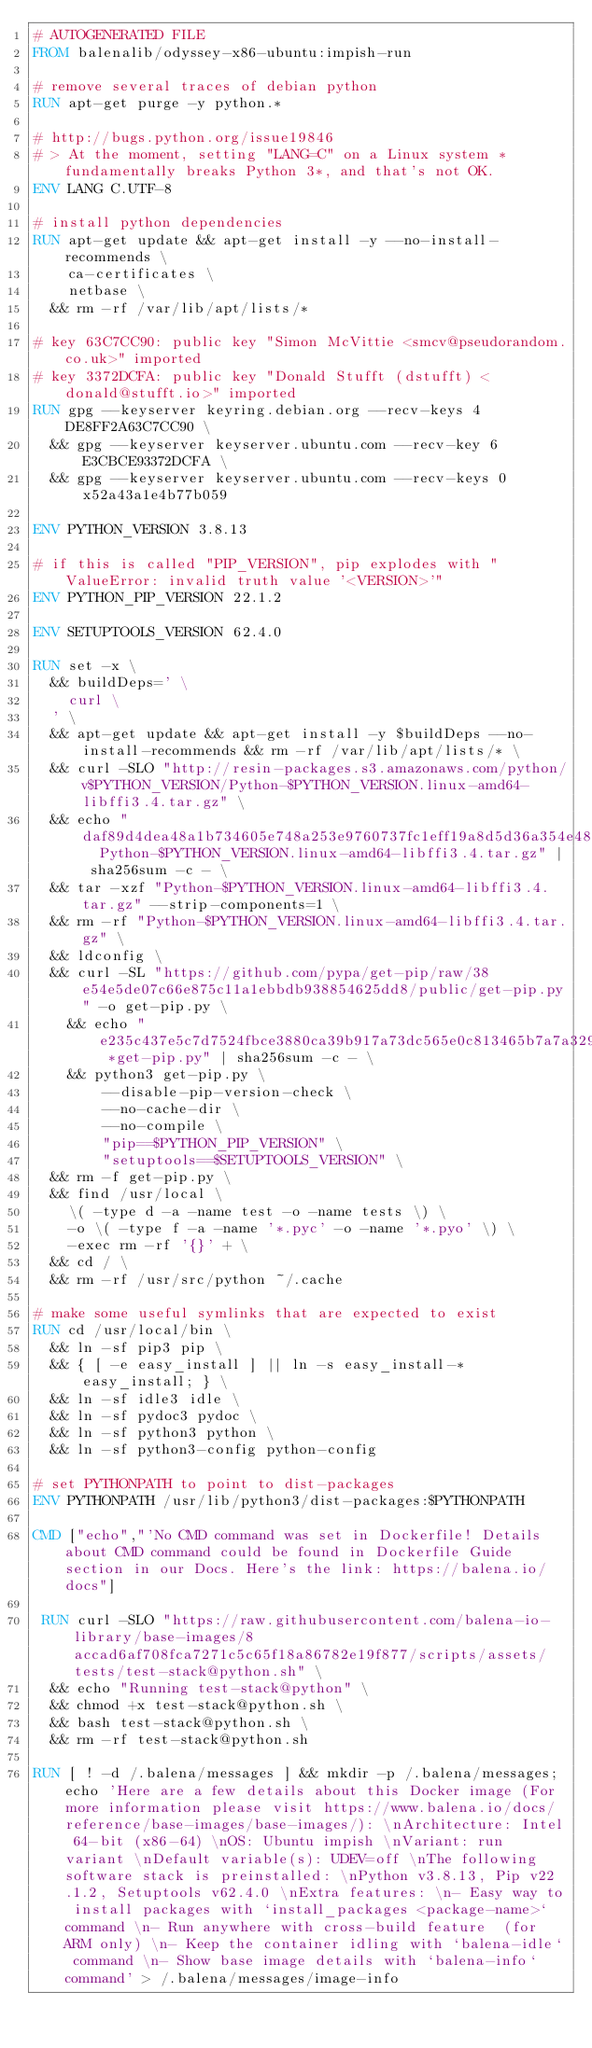<code> <loc_0><loc_0><loc_500><loc_500><_Dockerfile_># AUTOGENERATED FILE
FROM balenalib/odyssey-x86-ubuntu:impish-run

# remove several traces of debian python
RUN apt-get purge -y python.*

# http://bugs.python.org/issue19846
# > At the moment, setting "LANG=C" on a Linux system *fundamentally breaks Python 3*, and that's not OK.
ENV LANG C.UTF-8

# install python dependencies
RUN apt-get update && apt-get install -y --no-install-recommends \
		ca-certificates \
		netbase \
	&& rm -rf /var/lib/apt/lists/*

# key 63C7CC90: public key "Simon McVittie <smcv@pseudorandom.co.uk>" imported
# key 3372DCFA: public key "Donald Stufft (dstufft) <donald@stufft.io>" imported
RUN gpg --keyserver keyring.debian.org --recv-keys 4DE8FF2A63C7CC90 \
	&& gpg --keyserver keyserver.ubuntu.com --recv-key 6E3CBCE93372DCFA \
	&& gpg --keyserver keyserver.ubuntu.com --recv-keys 0x52a43a1e4b77b059

ENV PYTHON_VERSION 3.8.13

# if this is called "PIP_VERSION", pip explodes with "ValueError: invalid truth value '<VERSION>'"
ENV PYTHON_PIP_VERSION 22.1.2

ENV SETUPTOOLS_VERSION 62.4.0

RUN set -x \
	&& buildDeps=' \
		curl \
	' \
	&& apt-get update && apt-get install -y $buildDeps --no-install-recommends && rm -rf /var/lib/apt/lists/* \
	&& curl -SLO "http://resin-packages.s3.amazonaws.com/python/v$PYTHON_VERSION/Python-$PYTHON_VERSION.linux-amd64-libffi3.4.tar.gz" \
	&& echo "daf89d4dea48a1b734605e748a253e9760737fc1eff19a8d5d36a354e48fa8c8  Python-$PYTHON_VERSION.linux-amd64-libffi3.4.tar.gz" | sha256sum -c - \
	&& tar -xzf "Python-$PYTHON_VERSION.linux-amd64-libffi3.4.tar.gz" --strip-components=1 \
	&& rm -rf "Python-$PYTHON_VERSION.linux-amd64-libffi3.4.tar.gz" \
	&& ldconfig \
	&& curl -SL "https://github.com/pypa/get-pip/raw/38e54e5de07c66e875c11a1ebbdb938854625dd8/public/get-pip.py" -o get-pip.py \
    && echo "e235c437e5c7d7524fbce3880ca39b917a73dc565e0c813465b7a7a329bb279a *get-pip.py" | sha256sum -c - \
    && python3 get-pip.py \
        --disable-pip-version-check \
        --no-cache-dir \
        --no-compile \
        "pip==$PYTHON_PIP_VERSION" \
        "setuptools==$SETUPTOOLS_VERSION" \
	&& rm -f get-pip.py \
	&& find /usr/local \
		\( -type d -a -name test -o -name tests \) \
		-o \( -type f -a -name '*.pyc' -o -name '*.pyo' \) \
		-exec rm -rf '{}' + \
	&& cd / \
	&& rm -rf /usr/src/python ~/.cache

# make some useful symlinks that are expected to exist
RUN cd /usr/local/bin \
	&& ln -sf pip3 pip \
	&& { [ -e easy_install ] || ln -s easy_install-* easy_install; } \
	&& ln -sf idle3 idle \
	&& ln -sf pydoc3 pydoc \
	&& ln -sf python3 python \
	&& ln -sf python3-config python-config

# set PYTHONPATH to point to dist-packages
ENV PYTHONPATH /usr/lib/python3/dist-packages:$PYTHONPATH

CMD ["echo","'No CMD command was set in Dockerfile! Details about CMD command could be found in Dockerfile Guide section in our Docs. Here's the link: https://balena.io/docs"]

 RUN curl -SLO "https://raw.githubusercontent.com/balena-io-library/base-images/8accad6af708fca7271c5c65f18a86782e19f877/scripts/assets/tests/test-stack@python.sh" \
  && echo "Running test-stack@python" \
  && chmod +x test-stack@python.sh \
  && bash test-stack@python.sh \
  && rm -rf test-stack@python.sh 

RUN [ ! -d /.balena/messages ] && mkdir -p /.balena/messages; echo 'Here are a few details about this Docker image (For more information please visit https://www.balena.io/docs/reference/base-images/base-images/): \nArchitecture: Intel 64-bit (x86-64) \nOS: Ubuntu impish \nVariant: run variant \nDefault variable(s): UDEV=off \nThe following software stack is preinstalled: \nPython v3.8.13, Pip v22.1.2, Setuptools v62.4.0 \nExtra features: \n- Easy way to install packages with `install_packages <package-name>` command \n- Run anywhere with cross-build feature  (for ARM only) \n- Keep the container idling with `balena-idle` command \n- Show base image details with `balena-info` command' > /.balena/messages/image-info</code> 